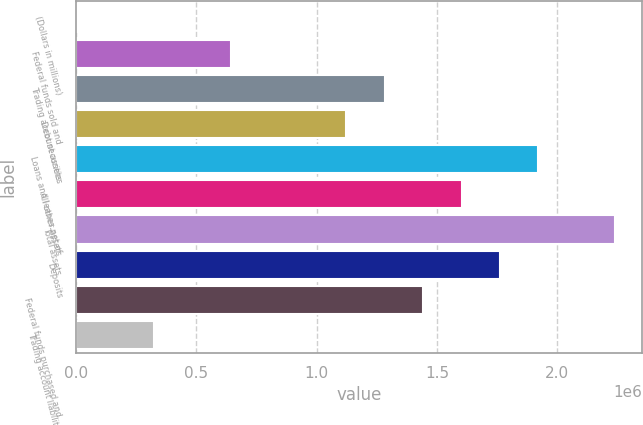Convert chart to OTSL. <chart><loc_0><loc_0><loc_500><loc_500><bar_chart><fcel>(Dollars in millions)<fcel>Federal funds sold and<fcel>Trading account assets<fcel>Debt securities<fcel>Loans and leases net of<fcel>All other assets<fcel>Total assets<fcel>Deposits<fcel>Federal funds purchased and<fcel>Trading account liabilities<nl><fcel>2007<fcel>642033<fcel>1.28206e+06<fcel>1.12205e+06<fcel>1.92209e+06<fcel>1.60207e+06<fcel>2.2421e+06<fcel>1.76208e+06<fcel>1.44207e+06<fcel>322020<nl></chart> 